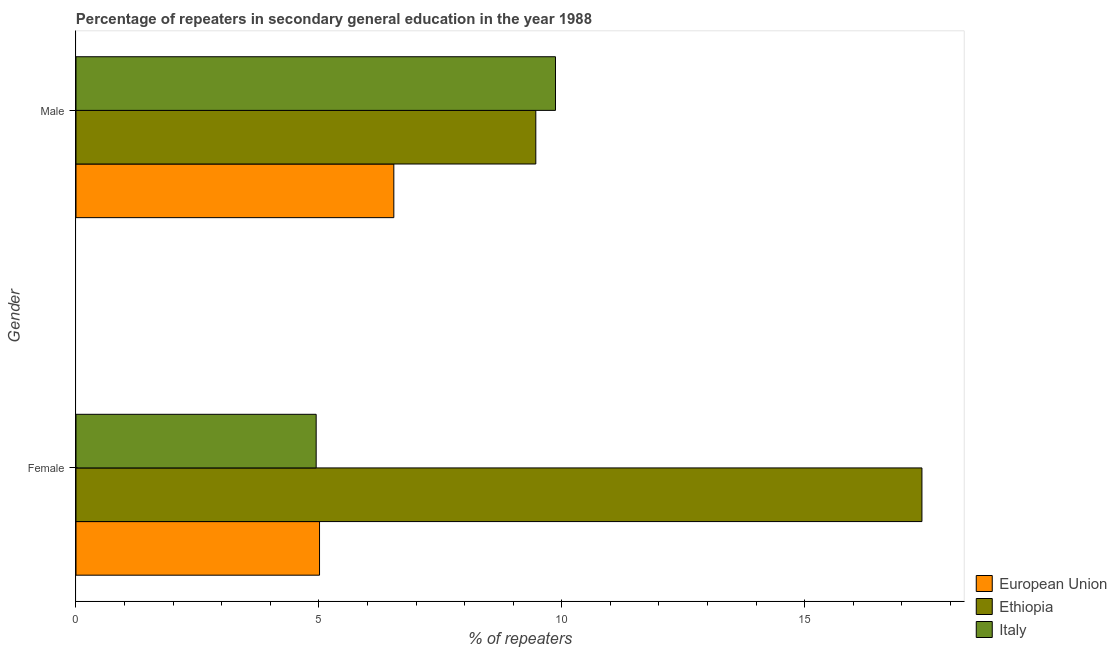How many different coloured bars are there?
Offer a very short reply. 3. What is the percentage of male repeaters in Ethiopia?
Offer a terse response. 9.47. Across all countries, what is the maximum percentage of male repeaters?
Make the answer very short. 9.87. Across all countries, what is the minimum percentage of female repeaters?
Your response must be concise. 4.94. In which country was the percentage of male repeaters maximum?
Ensure brevity in your answer.  Italy. In which country was the percentage of male repeaters minimum?
Offer a very short reply. European Union. What is the total percentage of male repeaters in the graph?
Ensure brevity in your answer.  25.88. What is the difference between the percentage of female repeaters in European Union and that in Ethiopia?
Your answer should be compact. -12.4. What is the difference between the percentage of male repeaters in Italy and the percentage of female repeaters in European Union?
Provide a succinct answer. 4.86. What is the average percentage of female repeaters per country?
Ensure brevity in your answer.  9.12. What is the difference between the percentage of male repeaters and percentage of female repeaters in European Union?
Your response must be concise. 1.53. In how many countries, is the percentage of female repeaters greater than 17 %?
Your response must be concise. 1. What is the ratio of the percentage of female repeaters in European Union to that in Ethiopia?
Your answer should be compact. 0.29. What does the 1st bar from the top in Female represents?
Your answer should be compact. Italy. Are all the bars in the graph horizontal?
Ensure brevity in your answer.  Yes. What is the difference between two consecutive major ticks on the X-axis?
Give a very brief answer. 5. Are the values on the major ticks of X-axis written in scientific E-notation?
Offer a terse response. No. Does the graph contain any zero values?
Your response must be concise. No. What is the title of the graph?
Make the answer very short. Percentage of repeaters in secondary general education in the year 1988. What is the label or title of the X-axis?
Give a very brief answer. % of repeaters. What is the % of repeaters of European Union in Female?
Your answer should be compact. 5.01. What is the % of repeaters of Ethiopia in Female?
Provide a succinct answer. 17.42. What is the % of repeaters of Italy in Female?
Keep it short and to the point. 4.94. What is the % of repeaters in European Union in Male?
Offer a terse response. 6.54. What is the % of repeaters in Ethiopia in Male?
Keep it short and to the point. 9.47. What is the % of repeaters in Italy in Male?
Offer a very short reply. 9.87. Across all Gender, what is the maximum % of repeaters of European Union?
Provide a short and direct response. 6.54. Across all Gender, what is the maximum % of repeaters of Ethiopia?
Make the answer very short. 17.42. Across all Gender, what is the maximum % of repeaters of Italy?
Your answer should be very brief. 9.87. Across all Gender, what is the minimum % of repeaters in European Union?
Your answer should be very brief. 5.01. Across all Gender, what is the minimum % of repeaters of Ethiopia?
Offer a very short reply. 9.47. Across all Gender, what is the minimum % of repeaters of Italy?
Provide a succinct answer. 4.94. What is the total % of repeaters of European Union in the graph?
Your answer should be compact. 11.56. What is the total % of repeaters in Ethiopia in the graph?
Offer a very short reply. 26.88. What is the total % of repeaters of Italy in the graph?
Make the answer very short. 14.82. What is the difference between the % of repeaters of European Union in Female and that in Male?
Give a very brief answer. -1.53. What is the difference between the % of repeaters in Ethiopia in Female and that in Male?
Offer a terse response. 7.95. What is the difference between the % of repeaters of Italy in Female and that in Male?
Offer a terse response. -4.93. What is the difference between the % of repeaters in European Union in Female and the % of repeaters in Ethiopia in Male?
Provide a succinct answer. -4.45. What is the difference between the % of repeaters in European Union in Female and the % of repeaters in Italy in Male?
Your answer should be very brief. -4.86. What is the difference between the % of repeaters in Ethiopia in Female and the % of repeaters in Italy in Male?
Offer a very short reply. 7.54. What is the average % of repeaters of European Union per Gender?
Give a very brief answer. 5.78. What is the average % of repeaters of Ethiopia per Gender?
Ensure brevity in your answer.  13.44. What is the average % of repeaters in Italy per Gender?
Provide a succinct answer. 7.41. What is the difference between the % of repeaters of European Union and % of repeaters of Ethiopia in Female?
Ensure brevity in your answer.  -12.4. What is the difference between the % of repeaters of European Union and % of repeaters of Italy in Female?
Your answer should be compact. 0.07. What is the difference between the % of repeaters in Ethiopia and % of repeaters in Italy in Female?
Your answer should be compact. 12.47. What is the difference between the % of repeaters in European Union and % of repeaters in Ethiopia in Male?
Your response must be concise. -2.92. What is the difference between the % of repeaters in European Union and % of repeaters in Italy in Male?
Keep it short and to the point. -3.33. What is the difference between the % of repeaters of Ethiopia and % of repeaters of Italy in Male?
Your answer should be compact. -0.4. What is the ratio of the % of repeaters in European Union in Female to that in Male?
Ensure brevity in your answer.  0.77. What is the ratio of the % of repeaters in Ethiopia in Female to that in Male?
Offer a terse response. 1.84. What is the ratio of the % of repeaters of Italy in Female to that in Male?
Offer a terse response. 0.5. What is the difference between the highest and the second highest % of repeaters in European Union?
Keep it short and to the point. 1.53. What is the difference between the highest and the second highest % of repeaters of Ethiopia?
Provide a succinct answer. 7.95. What is the difference between the highest and the second highest % of repeaters in Italy?
Your answer should be compact. 4.93. What is the difference between the highest and the lowest % of repeaters of European Union?
Your answer should be compact. 1.53. What is the difference between the highest and the lowest % of repeaters in Ethiopia?
Provide a short and direct response. 7.95. What is the difference between the highest and the lowest % of repeaters of Italy?
Make the answer very short. 4.93. 